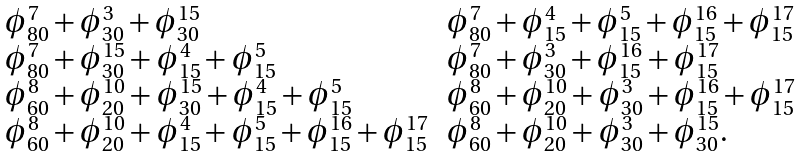<formula> <loc_0><loc_0><loc_500><loc_500>\begin{array} { l l } \phi _ { 8 0 } ^ { 7 } + \phi _ { 3 0 } ^ { 3 } + \phi _ { 3 0 } ^ { 1 5 } & \phi _ { 8 0 } ^ { 7 } + \phi _ { 1 5 } ^ { 4 } + \phi _ { 1 5 } ^ { 5 } + \phi _ { 1 5 } ^ { 1 6 } + \phi _ { 1 5 } ^ { 1 7 } \\ \phi _ { 8 0 } ^ { 7 } + \phi _ { 3 0 } ^ { 1 5 } + \phi _ { 1 5 } ^ { 4 } + \phi _ { 1 5 } ^ { 5 } & \phi _ { 8 0 } ^ { 7 } + \phi _ { 3 0 } ^ { 3 } + \phi _ { 1 5 } ^ { 1 6 } + \phi _ { 1 5 } ^ { 1 7 } \\ \phi _ { 6 0 } ^ { 8 } + \phi _ { 2 0 } ^ { 1 0 } + \phi _ { 3 0 } ^ { 1 5 } + \phi _ { 1 5 } ^ { 4 } + \phi _ { 1 5 } ^ { 5 } & \phi _ { 6 0 } ^ { 8 } + \phi _ { 2 0 } ^ { 1 0 } + \phi _ { 3 0 } ^ { 3 } + \phi _ { 1 5 } ^ { 1 6 } + \phi _ { 1 5 } ^ { 1 7 } \\ \phi _ { 6 0 } ^ { 8 } + \phi _ { 2 0 } ^ { 1 0 } + \phi _ { 1 5 } ^ { 4 } + \phi _ { 1 5 } ^ { 5 } + \phi _ { 1 5 } ^ { 1 6 } + \phi _ { 1 5 } ^ { 1 7 } & \phi _ { 6 0 } ^ { 8 } + \phi _ { 2 0 } ^ { 1 0 } + \phi _ { 3 0 } ^ { 3 } + \phi _ { 3 0 } ^ { 1 5 } . \\ \end{array}</formula> 